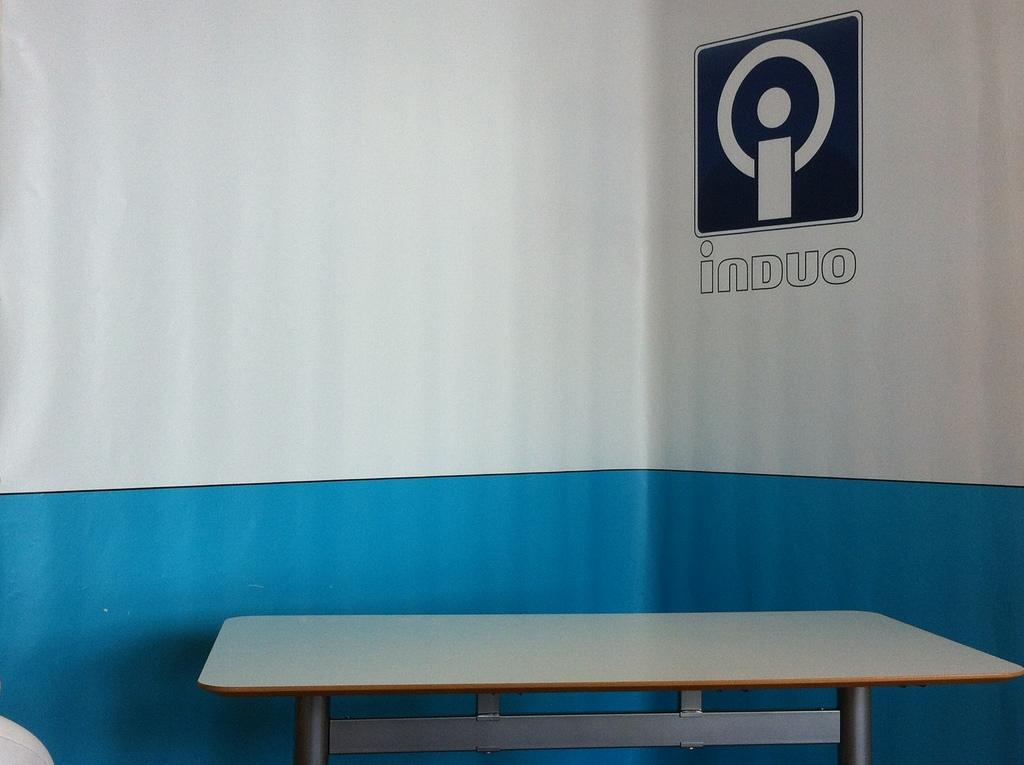What type of furniture is present in the image? There is a table in the image. What can be seen on the wall in the image? There is a logo and name on the wall in the image. What colors are used for the wall in the image? The wall in the image is white and blue in color. What type of sack is hanging on the wall in the image? There is no sack present in the image; the wall features a logo and name. What color is the dress worn by the person in the image? There is no person present in the image, so it is not possible to determine the color of any dress. 